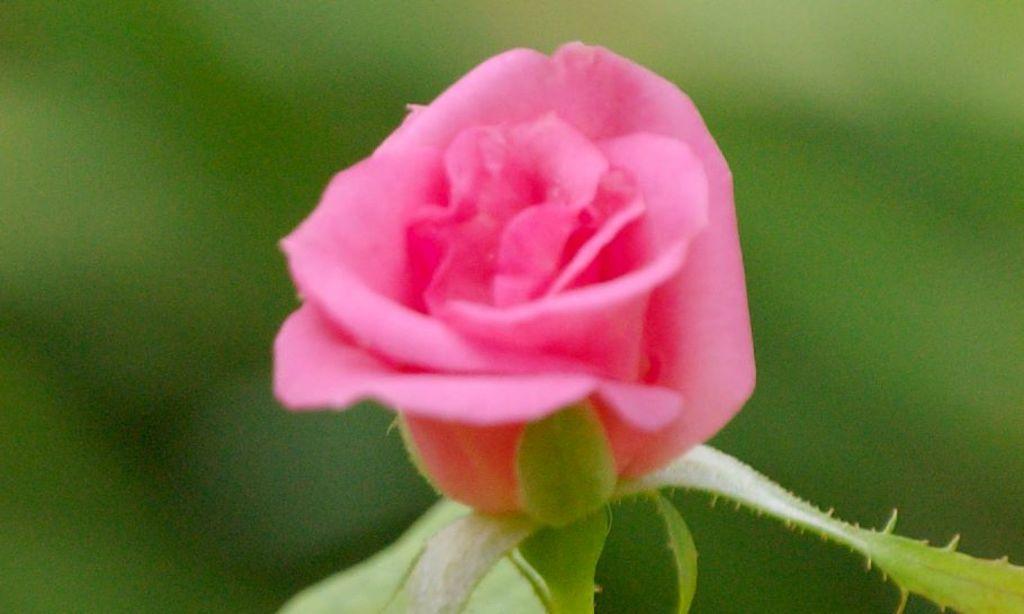Can you describe this image briefly? In this picture we can see a rose flower with leaves and in the background we can see trees it is blurry. 